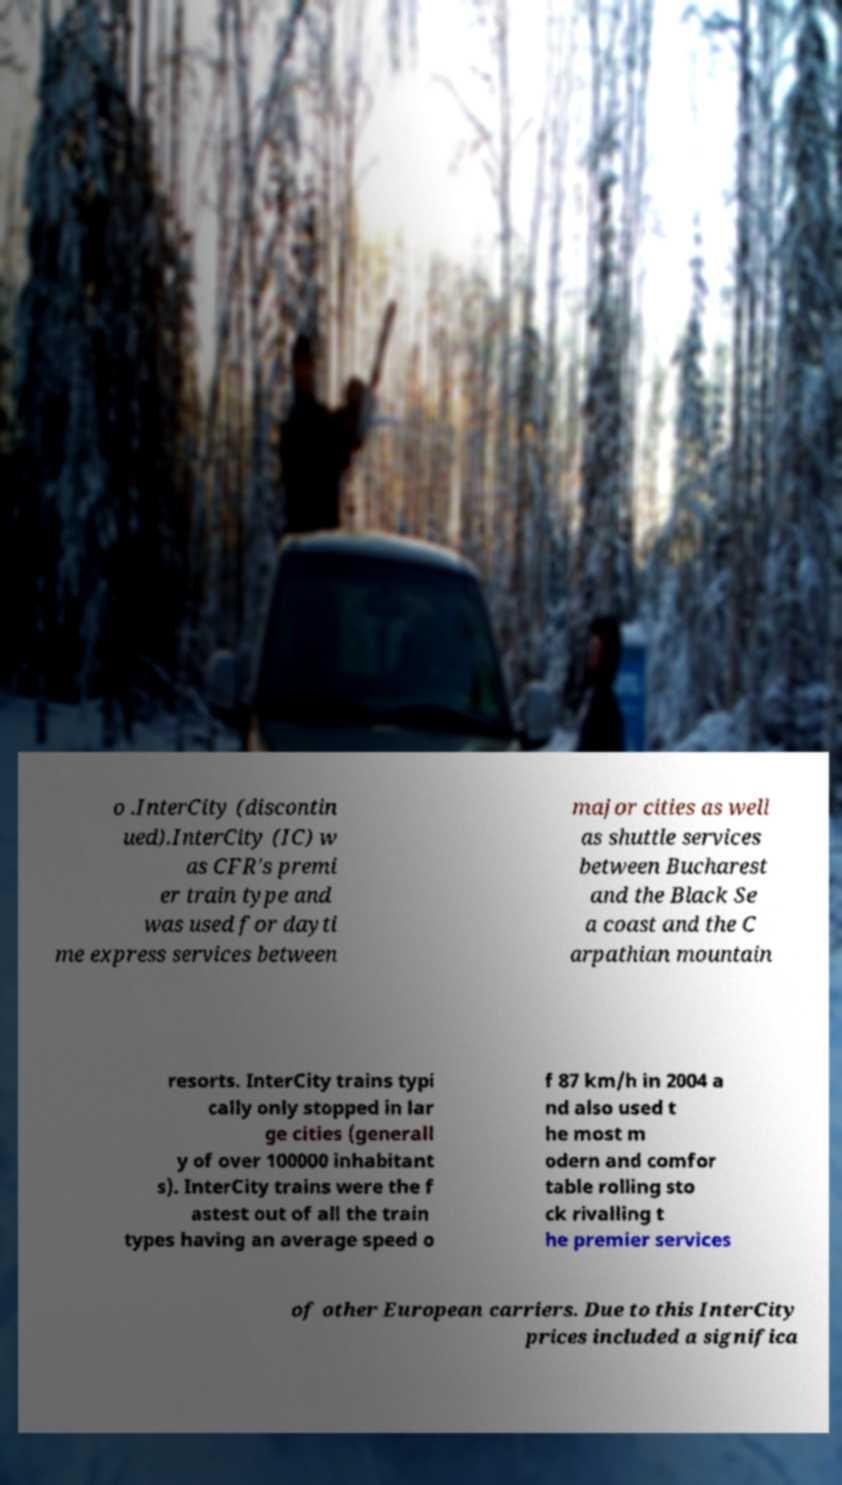What messages or text are displayed in this image? I need them in a readable, typed format. o .InterCity (discontin ued).InterCity (IC) w as CFR's premi er train type and was used for dayti me express services between major cities as well as shuttle services between Bucharest and the Black Se a coast and the C arpathian mountain resorts. InterCity trains typi cally only stopped in lar ge cities (generall y of over 100000 inhabitant s). InterCity trains were the f astest out of all the train types having an average speed o f 87 km/h in 2004 a nd also used t he most m odern and comfor table rolling sto ck rivalling t he premier services of other European carriers. Due to this InterCity prices included a significa 